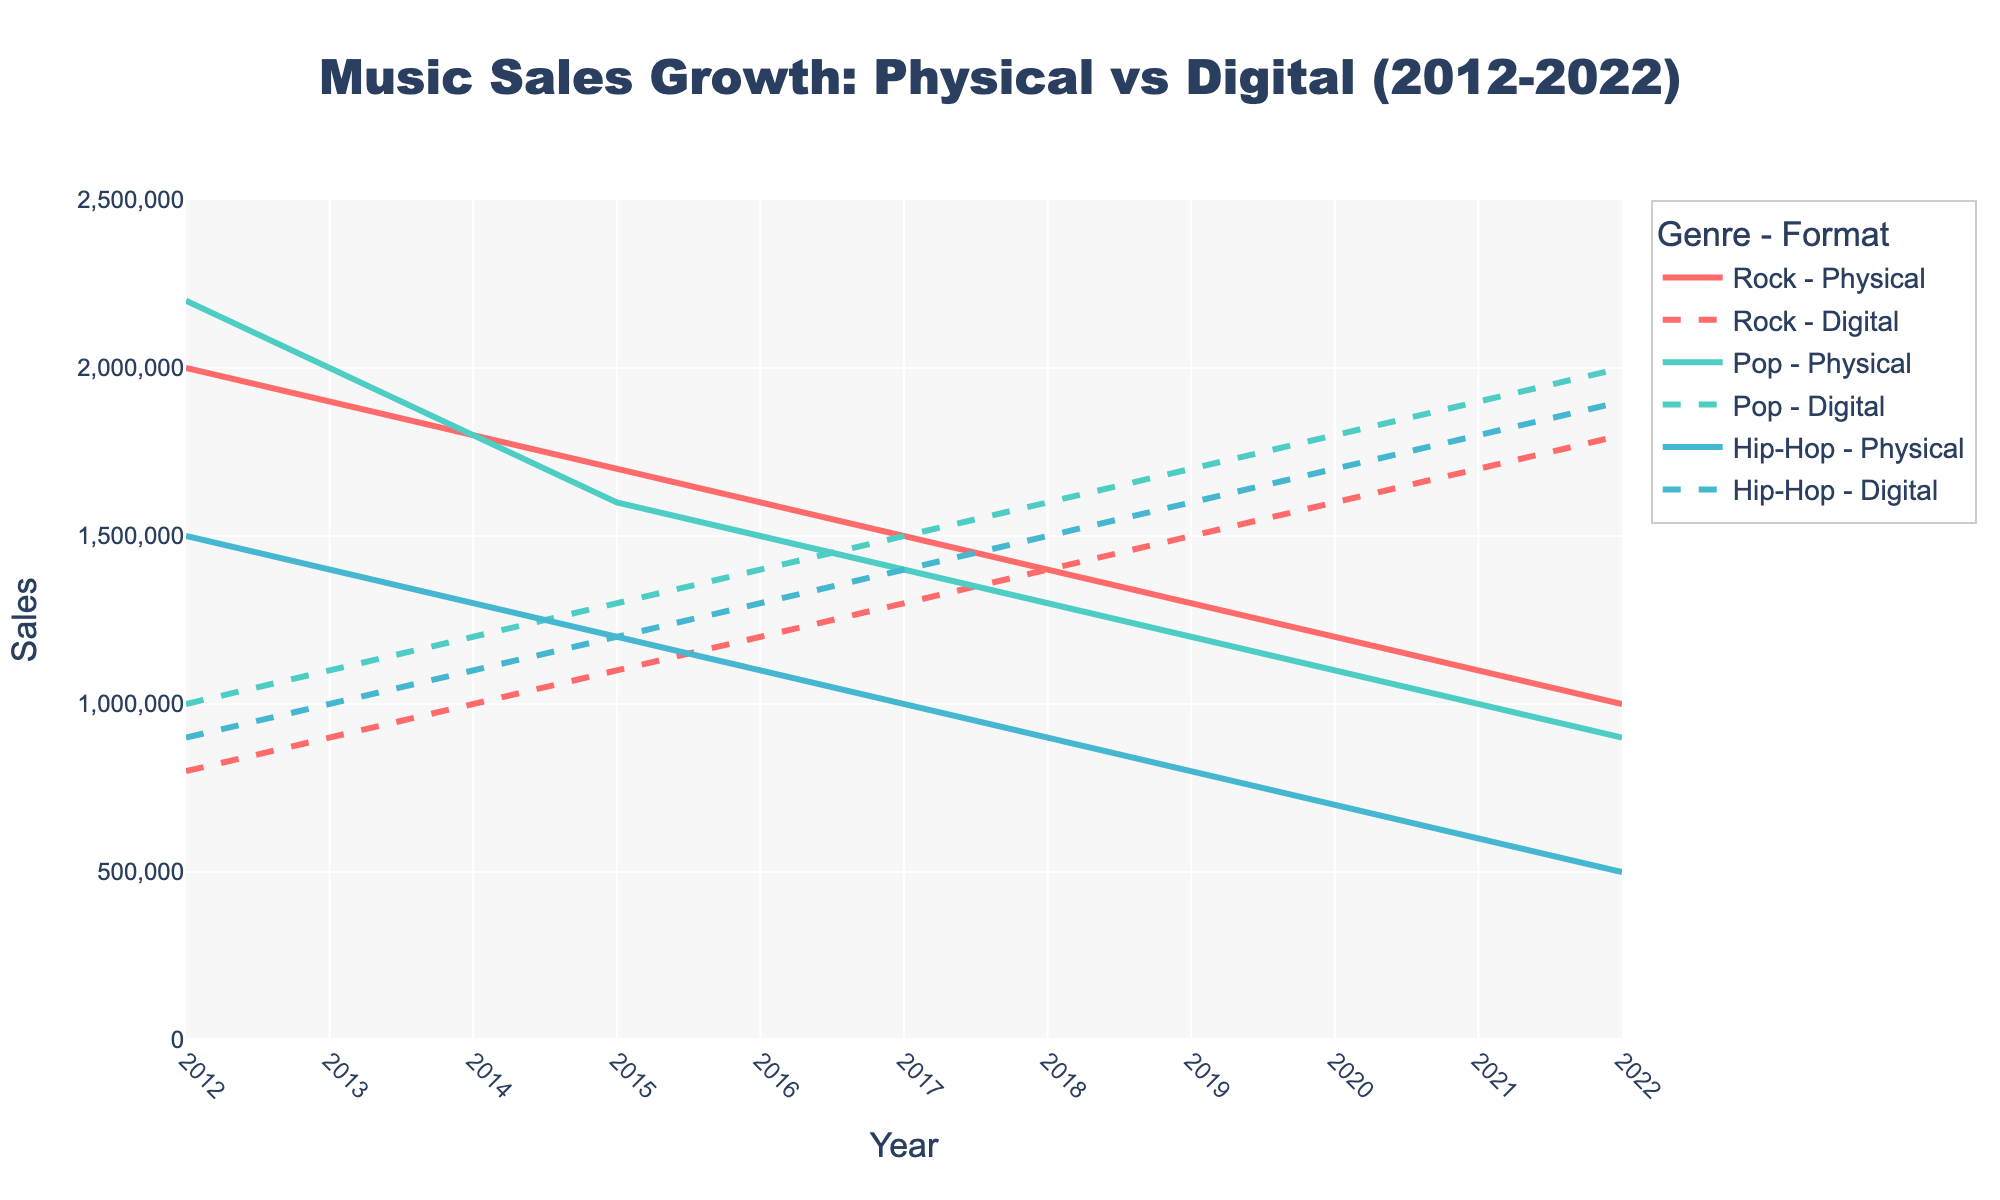What is the title of the figure? The title is located at the top center of the figure. It typically describes the overall content or focus. Here, the title reads "Music Sales Growth: Physical vs Digital (2012-2022)".
Answer: Music Sales Growth: Physical vs Digital (2012-2022) What are the x and y axes representing? The x-axis titles the "Year" and runs horizontally, while the y-axis titles "Sales" and runs vertically. These labels are usually found on the respective axes.
Answer: Year, Sales Which genre had the highest digital sales in 2022? Look at the endpoint of the digital lines in 2022. The Pop genre has the highest line at 2,000,000 sales.
Answer: Pop Which line style represents digital formats? Check the type of lines used for digital formats. Digital formats are represented by dashed lines as seen across the various genres.
Answer: Dashed How does Rock's physical sales trend from 2012 to 2022 compare to its digital sales in the same period? Observe the lines for Rock in both formats from 2012 to 2022. Rock's physical sales are decreasing over the years, while its digital sales are increasing.
Answer: Physical: Decreasing, Digital: Increasing What was the approximate y-intercept for Pop's physical sales in 2022? The y-intercept is where the line crosses the y-axis in the year 2022. For Pop's physical sales in 2022, it is approximately at 900,000.
Answer: 900,000 Which year did Hip-Hop's digital sales surpass its physical sales? Check where the digital and physical lines for Hip-Hop intersect. This intersection happens between 2013 and 2014.
Answer: 2013-2014 Were any genres' digital sales ever lower than their physical sales? Compare all years for each genre. Rock's digital vs physical sales cross at the early years. For instance, Rock’s digital sales were lower than physical sales until 2015.
Answer: Yes (e.g., Rock until 2015) Between 2020 and 2022, which genre saw the largest absolute increase in digital sales? Calculate the increase by subtracting sales in 2020 from those in 2022 for each genre. Pop saw an increase from 1,800,000 to 2,000,000, the largest among the three genres.
Answer: Pop Compare the digital sales trend for Hip-Hop and Rock from 2018 to 2022. Which one showed a steeper growth? Compare the slopes of the lines from 2018 to 2022 for both genres. Hip-Hop's line's slope is steeper than Rock's indicating faster growth in digital sales.
Answer: Hip-Hop 